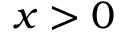Convert formula to latex. <formula><loc_0><loc_0><loc_500><loc_500>x > 0</formula> 